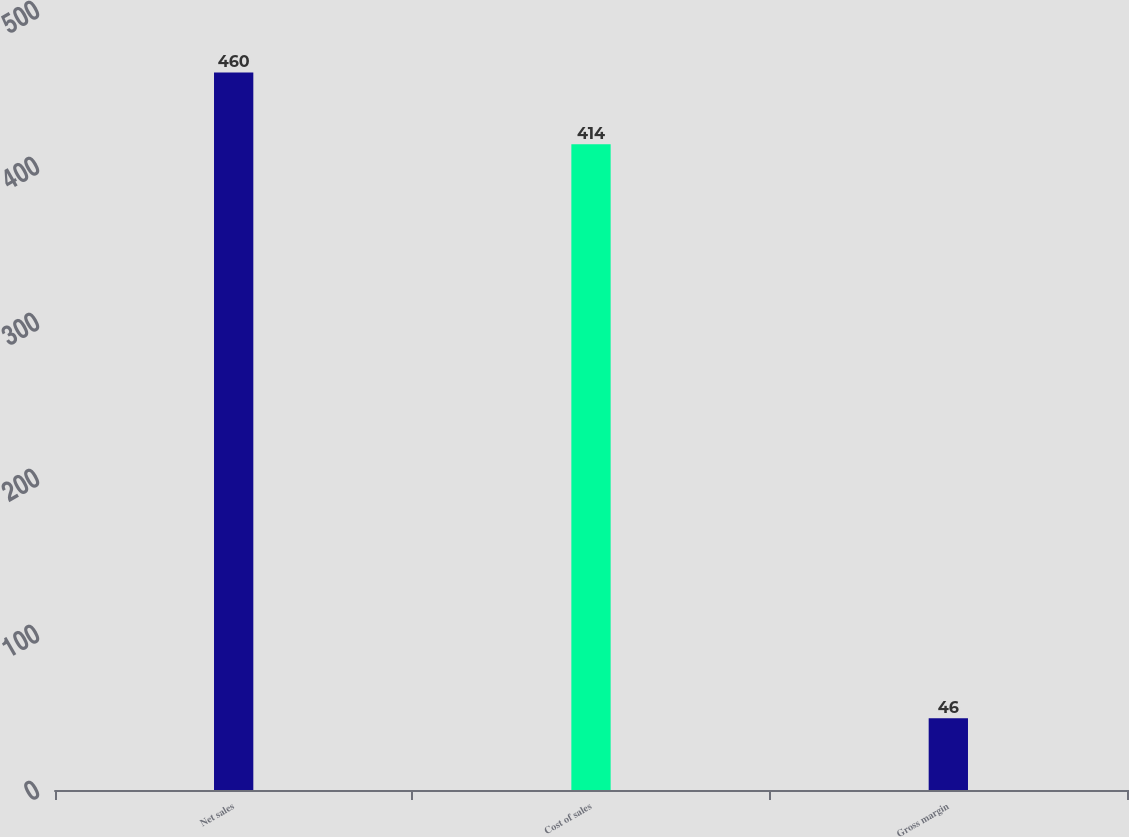Convert chart to OTSL. <chart><loc_0><loc_0><loc_500><loc_500><bar_chart><fcel>Net sales<fcel>Cost of sales<fcel>Gross margin<nl><fcel>460<fcel>414<fcel>46<nl></chart> 